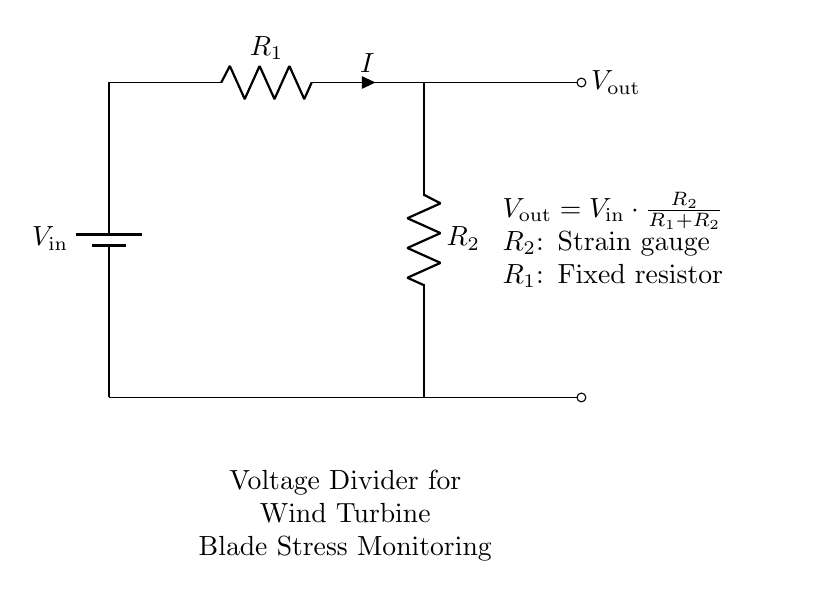What is the input voltage in this circuit? The input voltage, denoted as \(V_\text{in}\), is the voltage supplied to the circuit, but the exact value is not specified in the diagram.
Answer: \(V_\text{in}\) What are the resistances present in the circuit? The circuit contains two resistances: \(R_1\) which is a fixed resistor, and \(R_2\) which acts as a strain gauge.
Answer: \(R_1\) and \(R_2\) What is the output voltage formula? The output voltage, \(V_\text{out}\), is calculated using the formula: \(V_\text{out} = V_\text{in} \cdot \frac{R_2}{R_1 + R_2}\). This indicates how \(V_\text{out}\) depends on \(V_\text{in}\) and the resistor values.
Answer: \(V_\text{out} = V_\text{in} \cdot \frac{R_2}{R_1 + R_2}\) How does the strain gauge affect the output voltage? As \(R_2\) (the strain gauge) changes with stress applied to the wind turbine blades, it alters the output voltage \(V_\text{out}\), which allows for monitoring of the stress on the blades. Thus, increasing strain leads to a change in \(R_2\), affecting \(V_\text{out}\).
Answer: It varies \(V_\text{out}\) What type of circuit is represented here? The circuit is a voltage divider circuit, which is specifically designed to provide a reduced voltage output based on the ratio of the resistances involved in the division.
Answer: Voltage divider circuit 